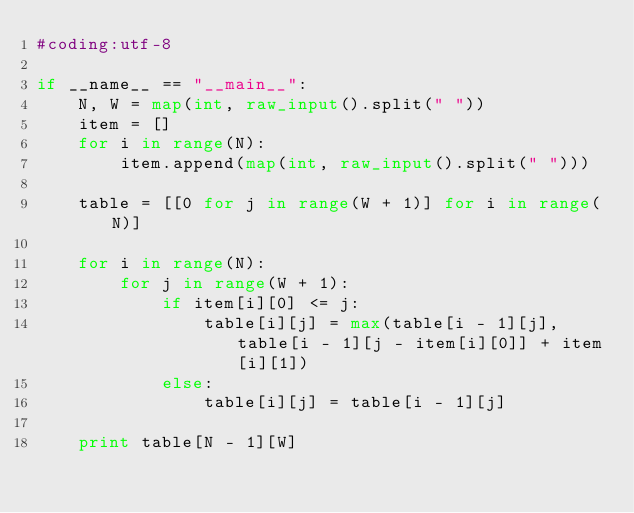<code> <loc_0><loc_0><loc_500><loc_500><_Python_>#coding:utf-8

if __name__ == "__main__":
    N, W = map(int, raw_input().split(" "))
    item = []
    for i in range(N):
        item.append(map(int, raw_input().split(" ")))

    table = [[0 for j in range(W + 1)] for i in range(N)]

    for i in range(N):
        for j in range(W + 1):
            if item[i][0] <= j:
                table[i][j] = max(table[i - 1][j], table[i - 1][j - item[i][0]] + item[i][1])
            else:
                table[i][j] = table[i - 1][j]

    print table[N - 1][W]
</code> 